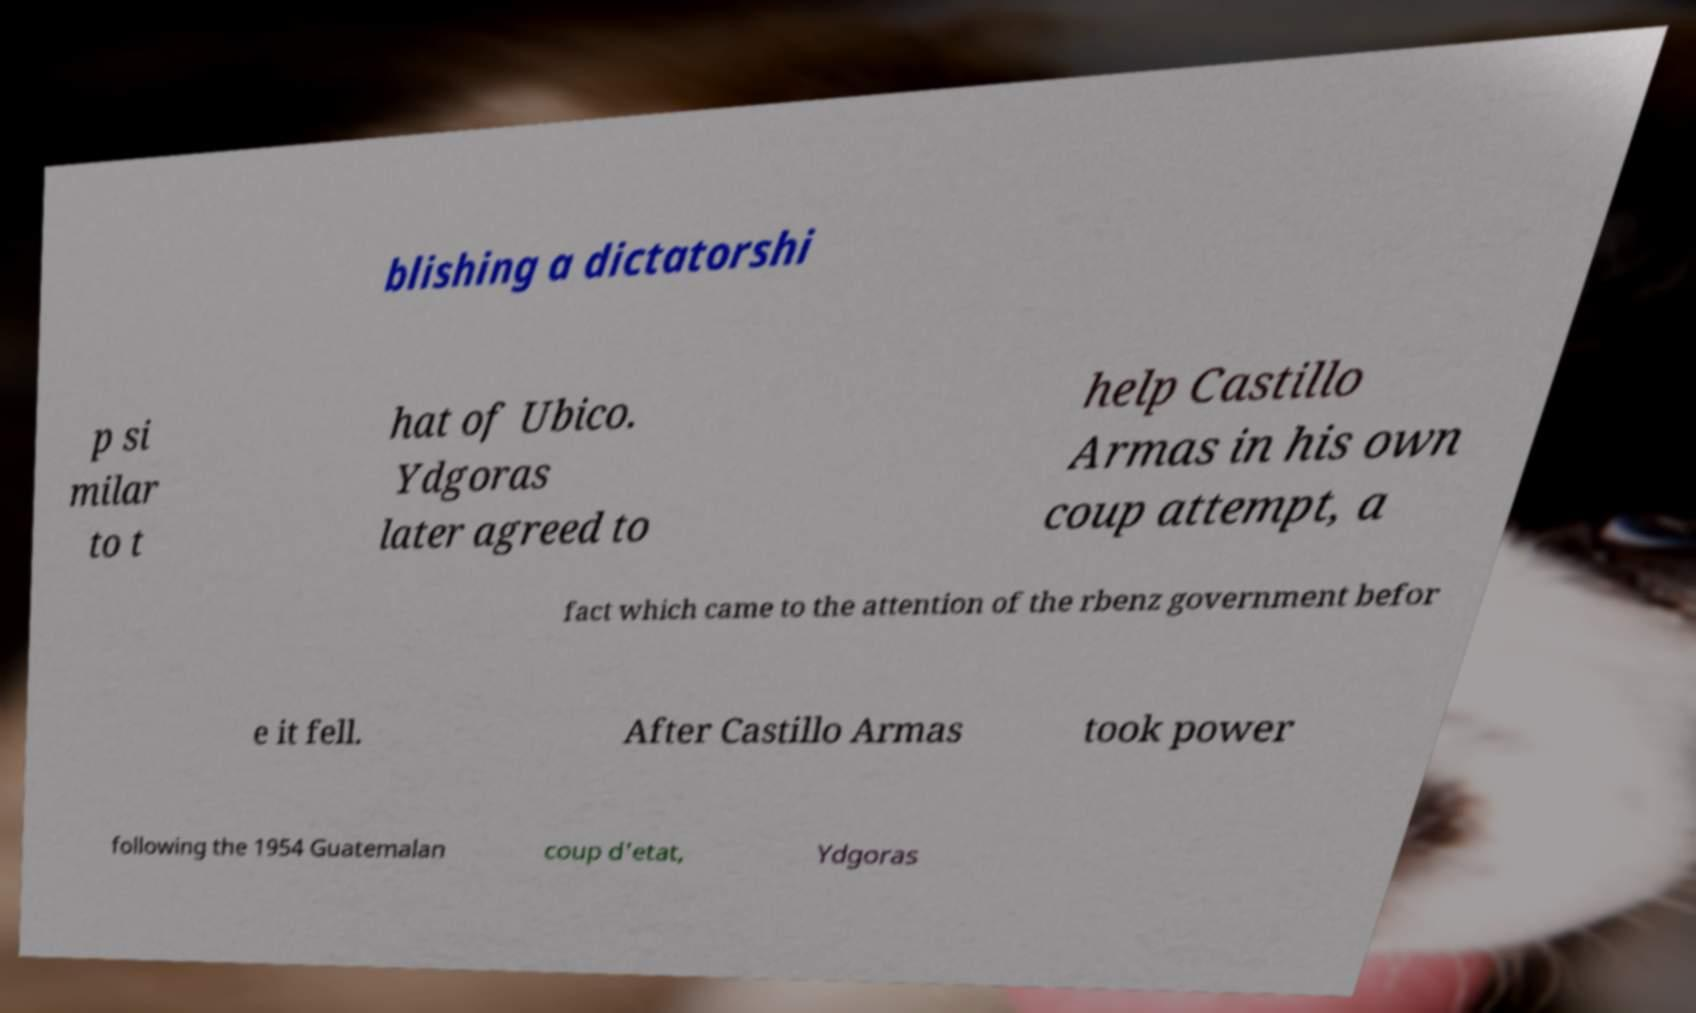Please read and relay the text visible in this image. What does it say? blishing a dictatorshi p si milar to t hat of Ubico. Ydgoras later agreed to help Castillo Armas in his own coup attempt, a fact which came to the attention of the rbenz government befor e it fell. After Castillo Armas took power following the 1954 Guatemalan coup d'etat, Ydgoras 